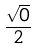Convert formula to latex. <formula><loc_0><loc_0><loc_500><loc_500>\frac { \sqrt { 0 } } { 2 }</formula> 